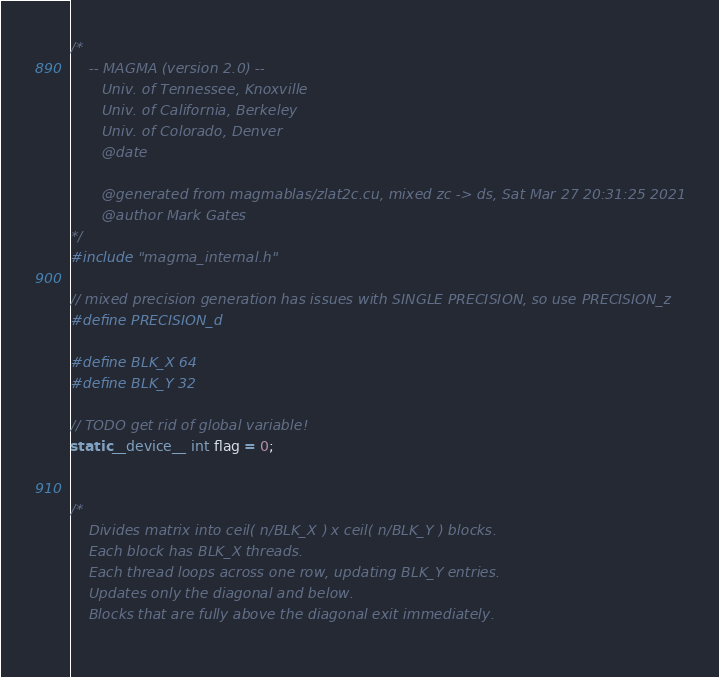Convert code to text. <code><loc_0><loc_0><loc_500><loc_500><_Cuda_>/*
    -- MAGMA (version 2.0) --
       Univ. of Tennessee, Knoxville
       Univ. of California, Berkeley
       Univ. of Colorado, Denver
       @date

       @generated from magmablas/zlat2c.cu, mixed zc -> ds, Sat Mar 27 20:31:25 2021
       @author Mark Gates
*/
#include "magma_internal.h"

// mixed precision generation has issues with SINGLE PRECISION, so use PRECISION_z
#define PRECISION_d

#define BLK_X 64
#define BLK_Y 32

// TODO get rid of global variable!
static __device__ int flag = 0;


/*
    Divides matrix into ceil( n/BLK_X ) x ceil( n/BLK_Y ) blocks.
    Each block has BLK_X threads.
    Each thread loops across one row, updating BLK_Y entries.
    Updates only the diagonal and below.
    Blocks that are fully above the diagonal exit immediately.
    </code> 